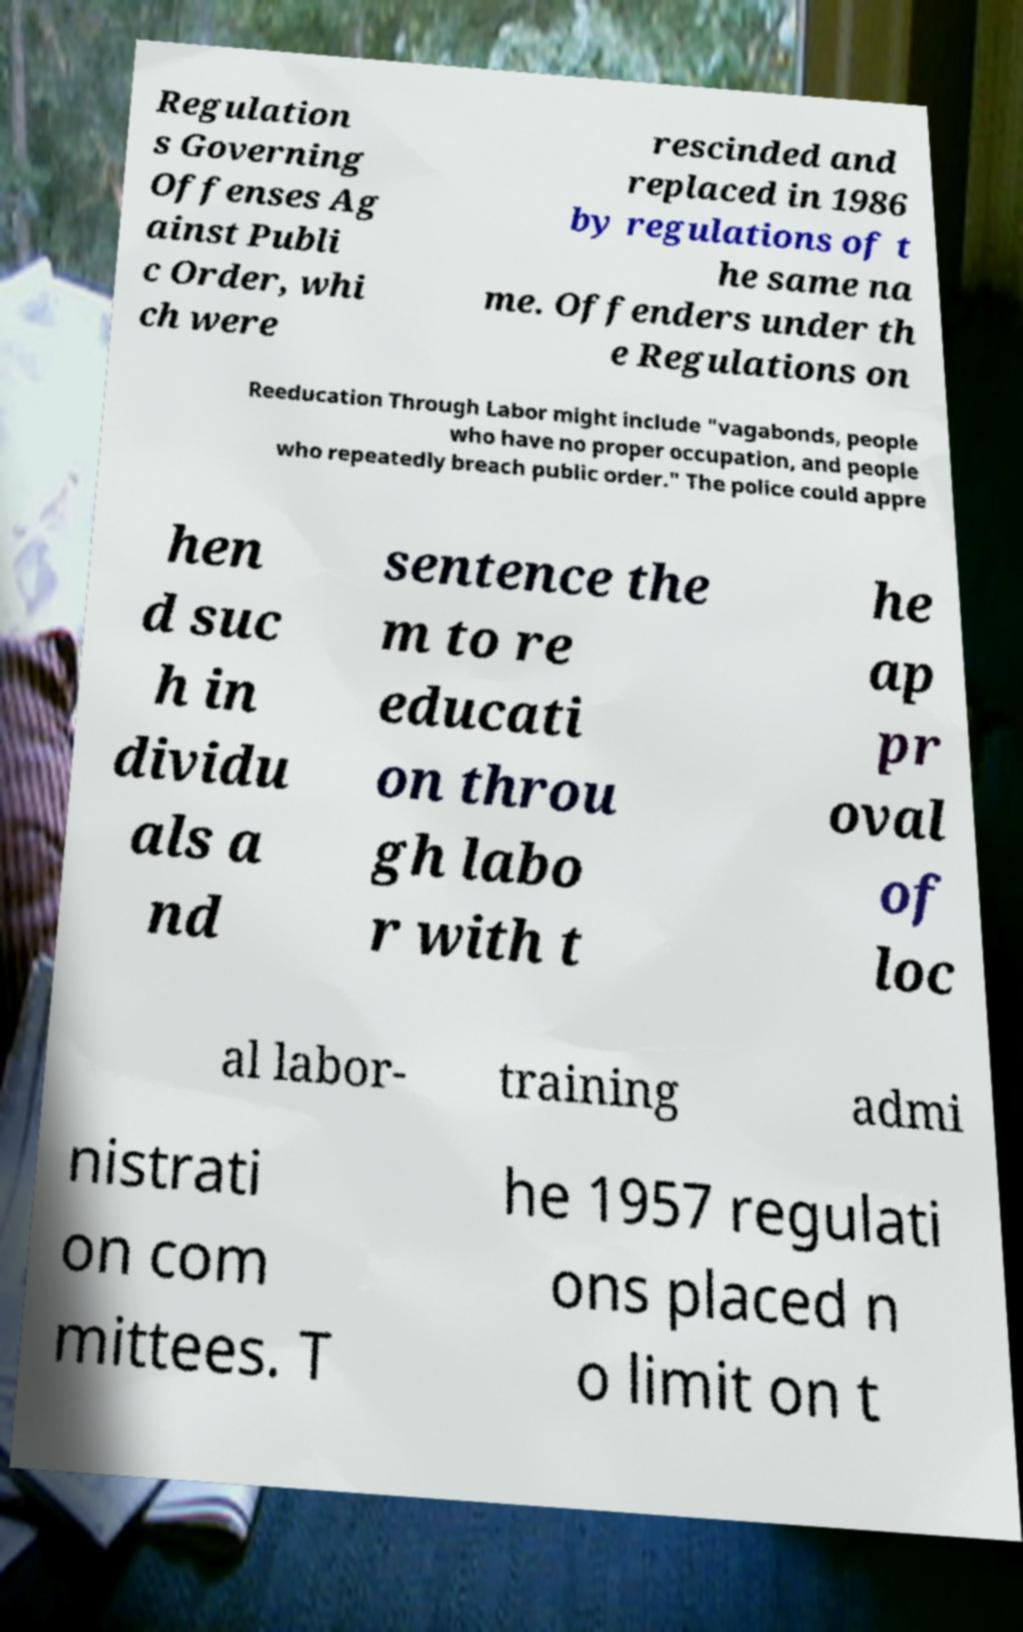Could you extract and type out the text from this image? Regulation s Governing Offenses Ag ainst Publi c Order, whi ch were rescinded and replaced in 1986 by regulations of t he same na me. Offenders under th e Regulations on Reeducation Through Labor might include "vagabonds, people who have no proper occupation, and people who repeatedly breach public order." The police could appre hen d suc h in dividu als a nd sentence the m to re educati on throu gh labo r with t he ap pr oval of loc al labor- training admi nistrati on com mittees. T he 1957 regulati ons placed n o limit on t 